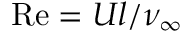Convert formula to latex. <formula><loc_0><loc_0><loc_500><loc_500>R e = U l / \nu _ { \infty }</formula> 